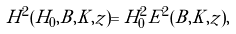Convert formula to latex. <formula><loc_0><loc_0><loc_500><loc_500>H ^ { 2 } ( H _ { 0 } , B , K , z ) = H ^ { 2 } _ { 0 } E ^ { 2 } ( B , K , z ) ,</formula> 